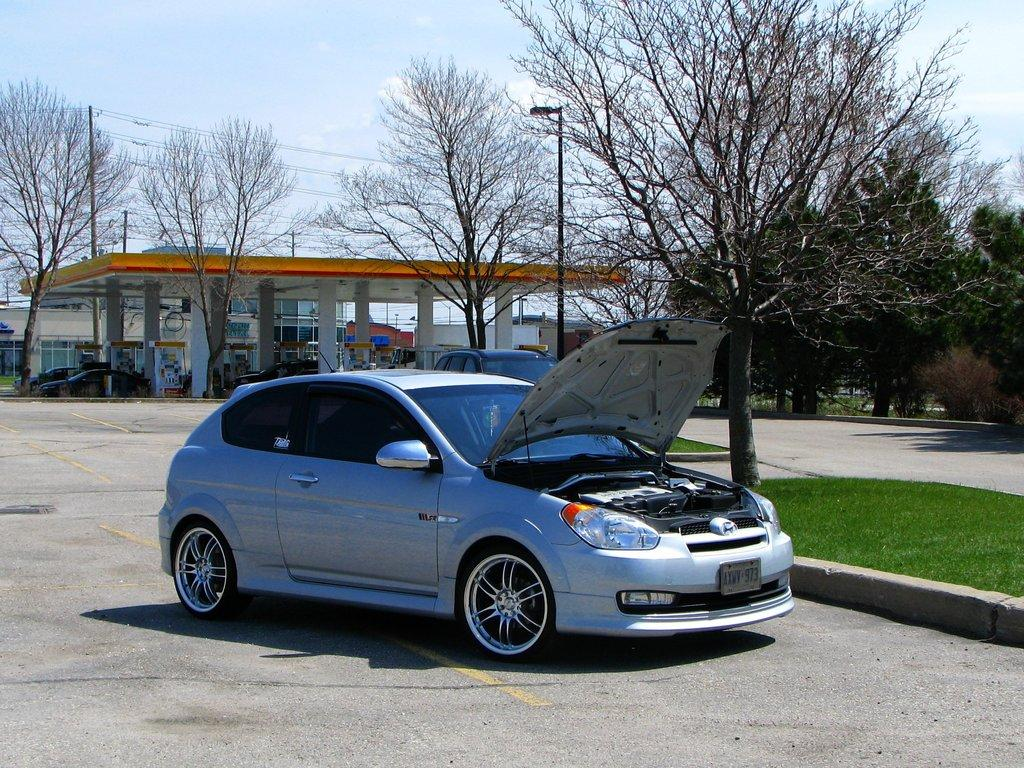What can be seen on the road in the image? There are cars on the road in the image. What type of vegetation is present beside the car? There is grass on the surface beside the car. What type of establishment is located at the back side of the image? There is a petrol bunk at the back side of the image. What can be seen in the background of the image? Trees and the sky are visible in the background of the image. What type of plot is being used to grow the grass beside the car? There is no information about the type of plot used to grow the grass beside the car in the image. Can you see the driver's neck in any of the cars in the image? There is no information about the drivers or their necks in the image. 